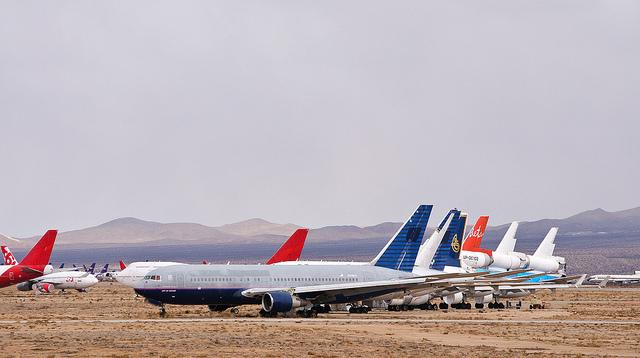What is the blue back piece of the plane called? Please explain your reasoning. fin. It is aerodynamic and helps to steer the plane. 